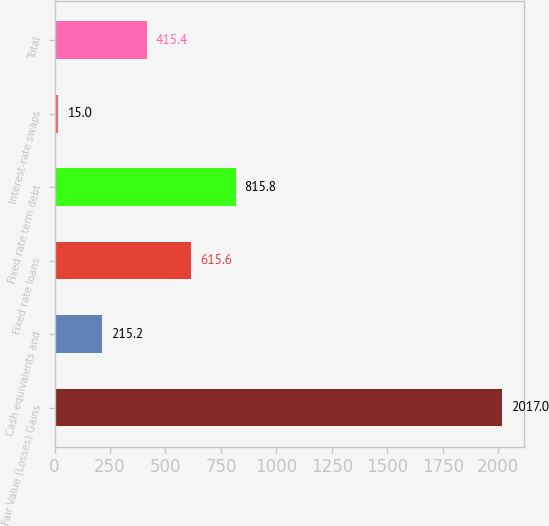<chart> <loc_0><loc_0><loc_500><loc_500><bar_chart><fcel>Fair Value (Losses) Gains<fcel>Cash equivalents and<fcel>Fixed rate loans<fcel>Fixed rate term debt<fcel>Interest-rate swaps<fcel>Total<nl><fcel>2017<fcel>215.2<fcel>615.6<fcel>815.8<fcel>15<fcel>415.4<nl></chart> 